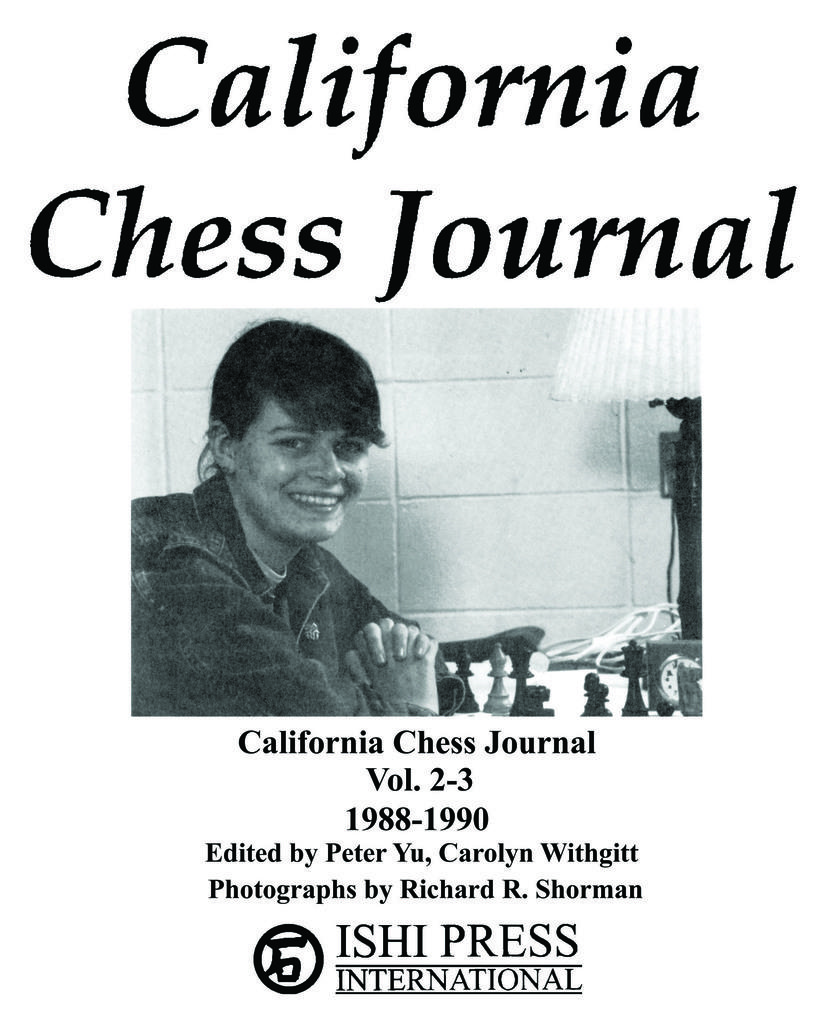What type of visual content is depicted in the image? The image is a poster. Who or what is the main subject of the poster? There is a woman in the image. What is the woman doing in the image? The woman is sitting and smiling. What is present on the table in the image? There are chess pieces on the table. What can be seen behind the woman in the image? There is a wall behind the woman. What type of bread is the woman holding in the image? There is no bread present in the image; the woman is sitting and smiling, and there are chess pieces on the table. Why is the woman crying in the image? The woman is not crying in the image; she is sitting and smiling. 